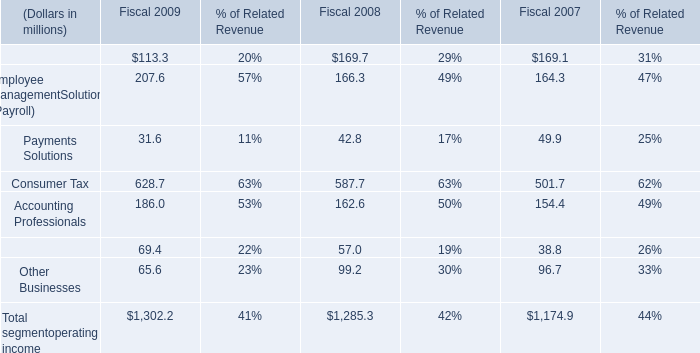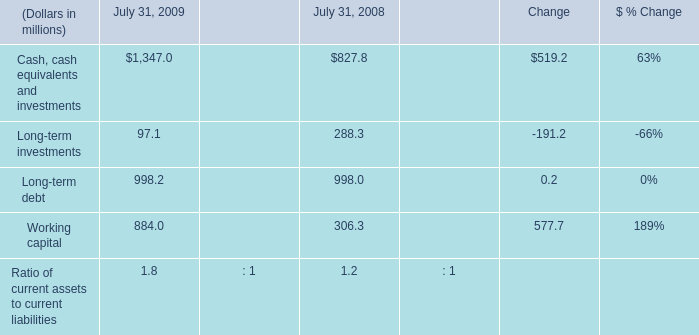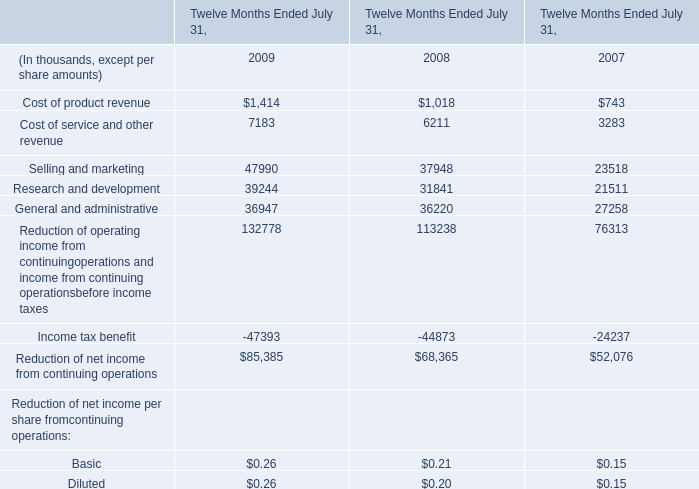What's the sum of Selling and marketing of Twelve Months Ended July 31, 2008, and Cash, cash equivalents and investments of July 31, 2009 ? 
Computations: (37948.0 + 1347.0)
Answer: 39295.0. 